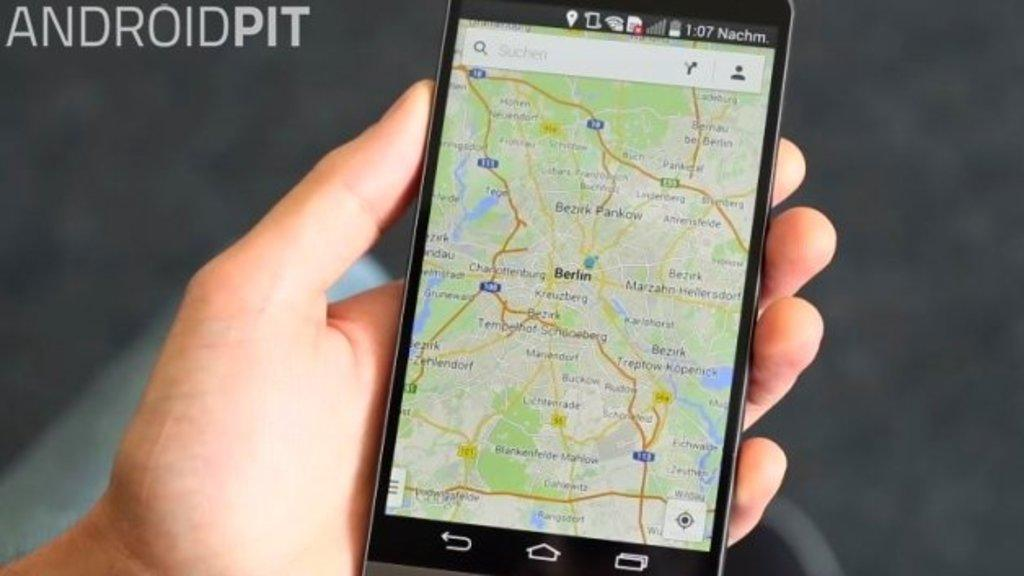<image>
Relay a brief, clear account of the picture shown. a cell phone display showing a map next to a sign reading Android Pit 